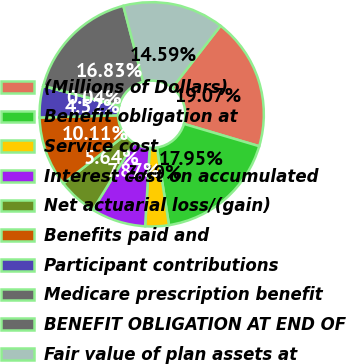Convert chart. <chart><loc_0><loc_0><loc_500><loc_500><pie_chart><fcel>(Millions of Dollars)<fcel>Benefit obligation at<fcel>Service cost<fcel>Interest cost on accumulated<fcel>Net actuarial loss/(gain)<fcel>Benefits paid and<fcel>Participant contributions<fcel>Medicare prescription benefit<fcel>BENEFIT OBLIGATION AT END OF<fcel>Fair value of plan assets at<nl><fcel>19.07%<fcel>17.95%<fcel>3.4%<fcel>7.87%<fcel>5.64%<fcel>10.11%<fcel>4.52%<fcel>0.04%<fcel>16.83%<fcel>14.59%<nl></chart> 